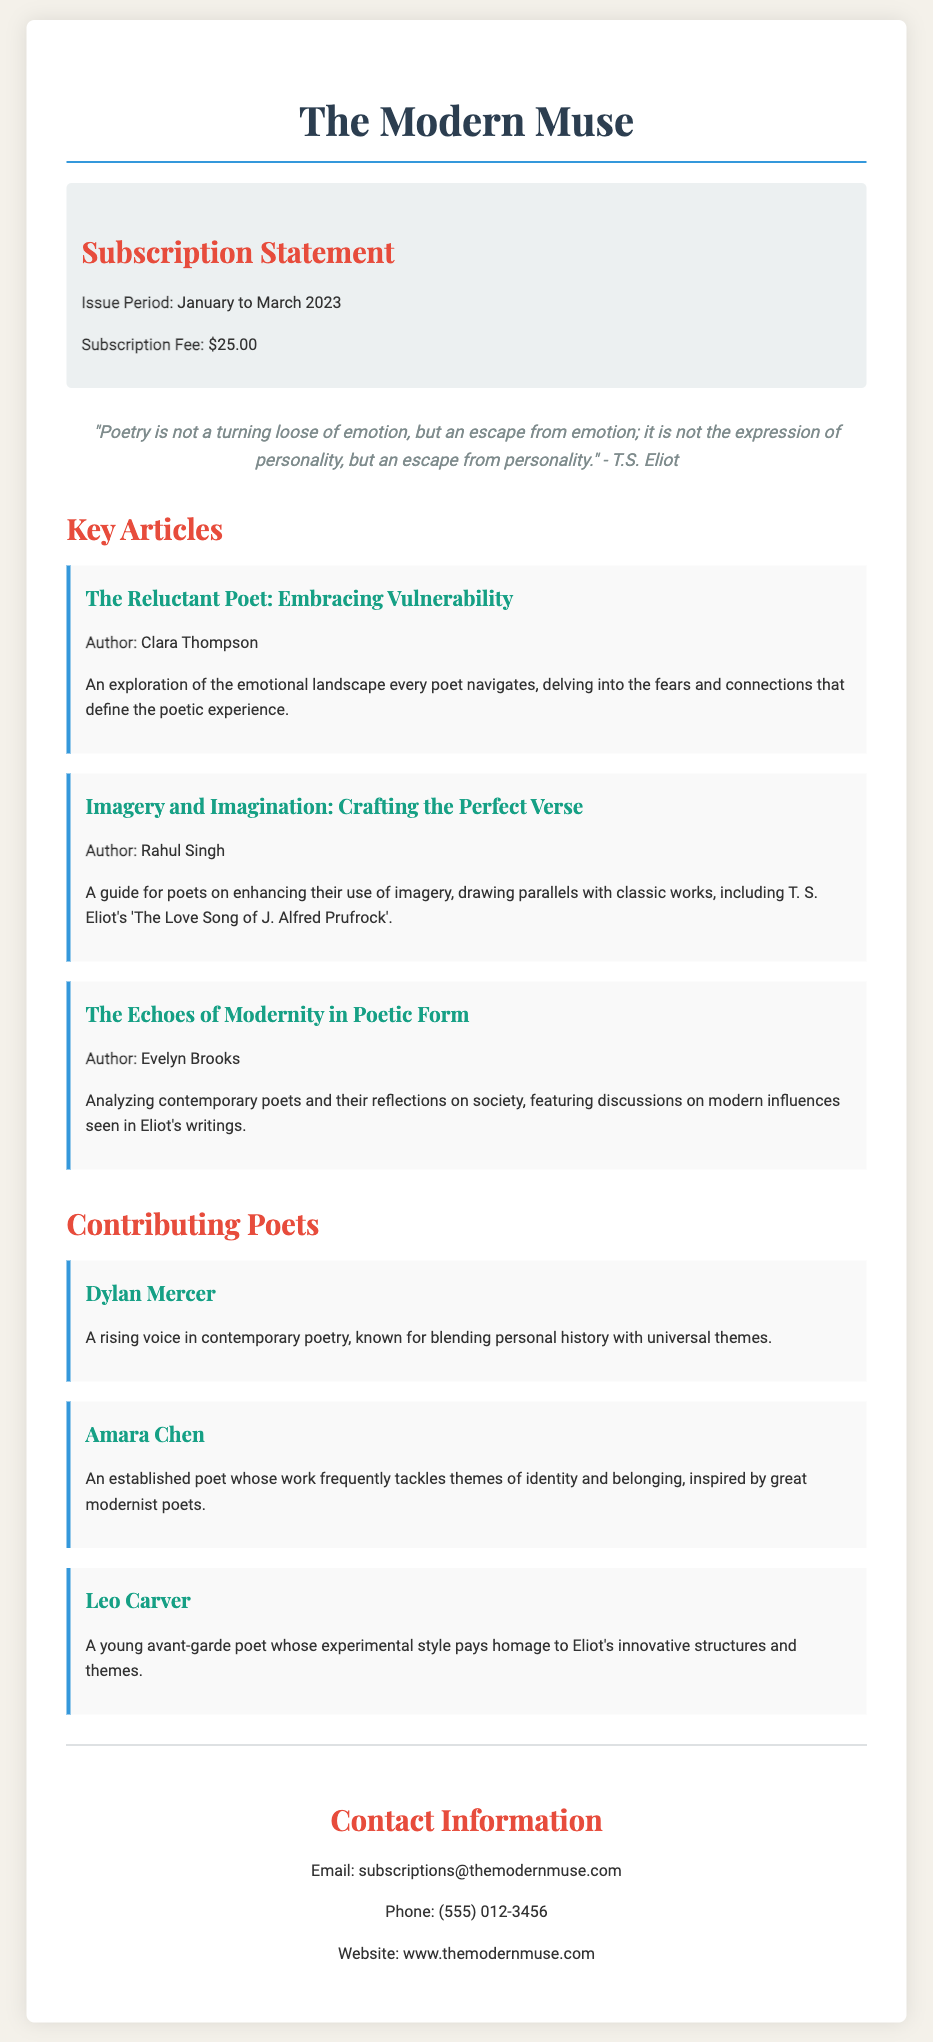What is the subscription fee? The subscription fee is listed in the document under the subscription information section.
Answer: $25.00 What is the issue period for the subscription statement? The issue period is specified in the subscription information part of the document.
Answer: January to March 2023 Who wrote "The Reluctant Poet: Embracing Vulnerability"? The author's name is provided under the corresponding article in the key articles section.
Answer: Clara Thompson Which article discusses T. S. Eliot's work? This requires integrating information from both the article title and the author mentioned in the key articles section.
Answer: Imagery and Imagination: Crafting the Perfect Verse Name one contributing poet featured in the document. The document lists multiple contributing poets, and any name mentioned is acceptable.
Answer: Dylan Mercer How is Leo Carver described? This information is detailed in the poet's description under the contributing poets section.
Answer: A young avant-garde poet whose experimental style pays homage to Eliot's innovative structures and themes What notable quote is included in the document? The quote is displayed prominently in the document and reflects a viewpoint aligned with T.S. Eliot's philosophy.
Answer: "Poetry is not a turning loose of emotion, but an escape from emotion; it is not the expression of personality, but an escape from personality." What is the contact email provided in the document? The contact email is mentioned in the contact information section.
Answer: subscriptions@themodernmuse.com 